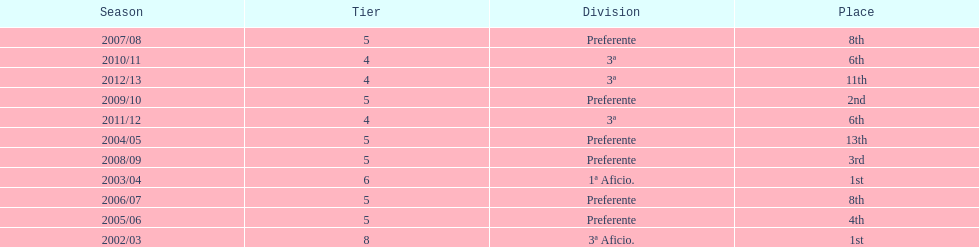Which division has the largest number of ranks? Preferente. 